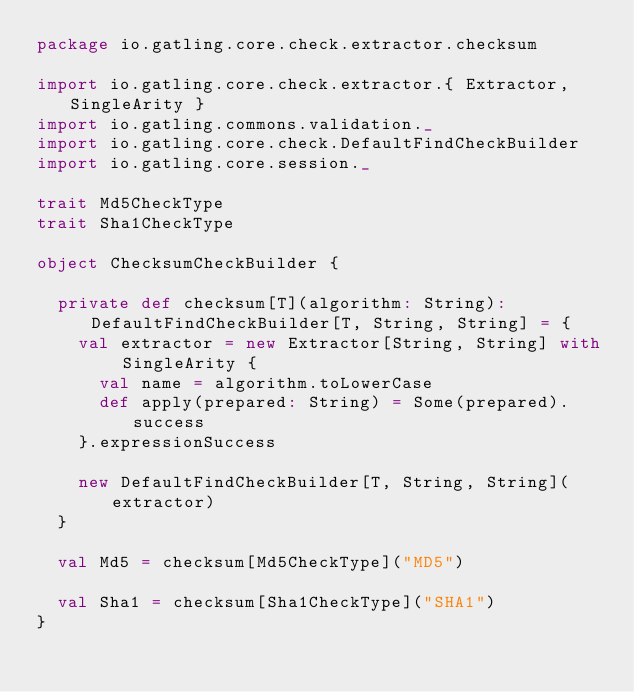Convert code to text. <code><loc_0><loc_0><loc_500><loc_500><_Scala_>package io.gatling.core.check.extractor.checksum

import io.gatling.core.check.extractor.{ Extractor, SingleArity }
import io.gatling.commons.validation._
import io.gatling.core.check.DefaultFindCheckBuilder
import io.gatling.core.session._

trait Md5CheckType
trait Sha1CheckType

object ChecksumCheckBuilder {

  private def checksum[T](algorithm: String): DefaultFindCheckBuilder[T, String, String] = {
    val extractor = new Extractor[String, String] with SingleArity {
      val name = algorithm.toLowerCase
      def apply(prepared: String) = Some(prepared).success
    }.expressionSuccess

    new DefaultFindCheckBuilder[T, String, String](extractor)
  }

  val Md5 = checksum[Md5CheckType]("MD5")

  val Sha1 = checksum[Sha1CheckType]("SHA1")
}
</code> 